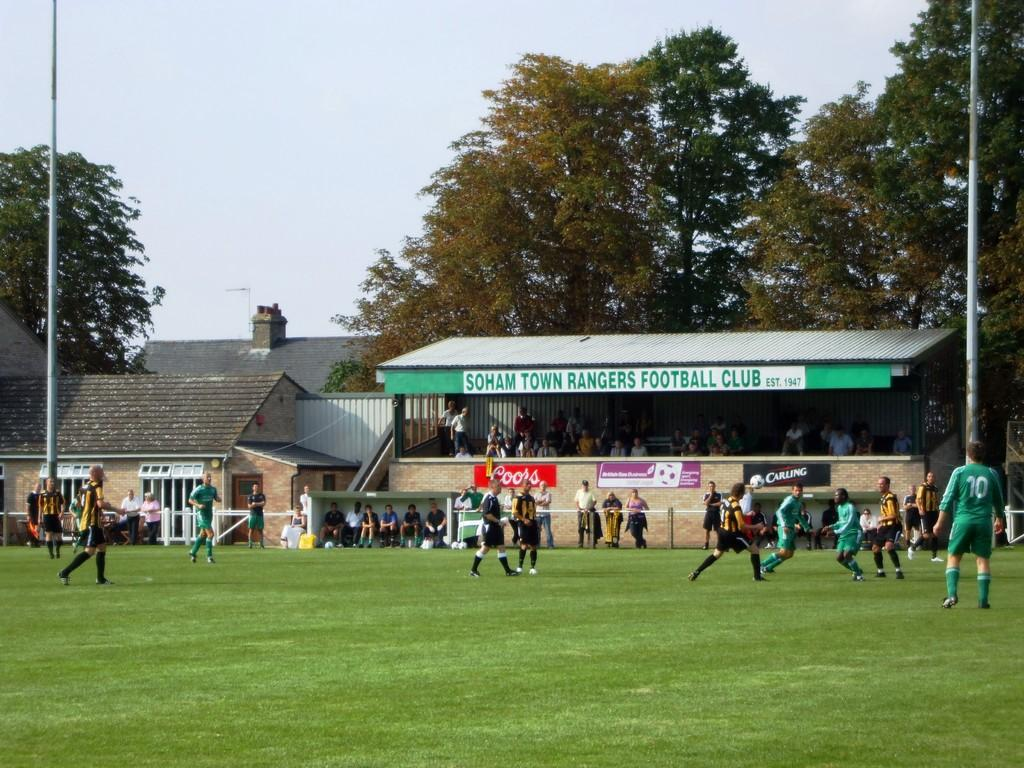<image>
Offer a succinct explanation of the picture presented. Soccer plays stand on the field at the Soham Town Rangers Football Club 